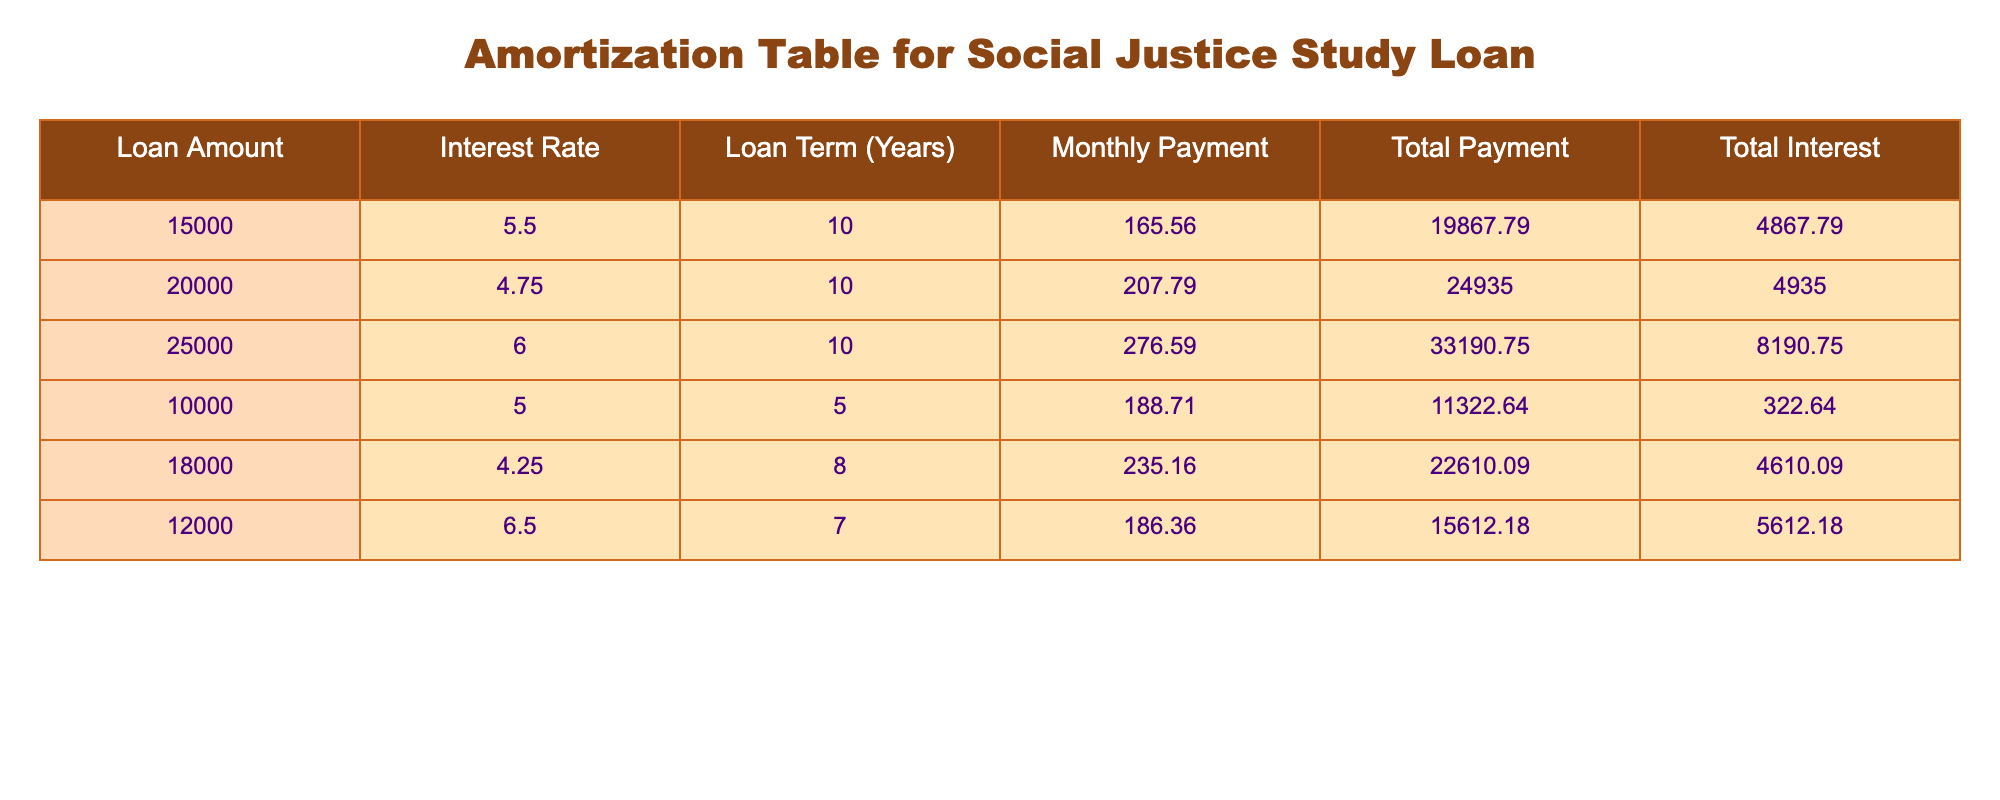What is the loan amount for the lowest total interest? Looking at the total interest column, the lowest total interest value is 322.64, which corresponds to the loan amount of 10,000.
Answer: 10000 Which loan has the highest monthly payment? The monthly payment column indicates that the loan with the highest monthly payment is 276.59, which corresponds to the loan amount of 25,000.
Answer: 25000 What is the total payment for a loan of 20,000? Referring to the total payment column, the total payment for the loan amount of 20,000 is 24,935.
Answer: 24935 Is the interest rate for the 12,000 loan higher than 5%? The interest rate for the loan amount of 12,000 is 6.5%, which is indeed higher than 5%.
Answer: Yes What is the total interest for a loan amount of 18,000? In the total interest column, for the loan amount of 18,000, the total interest is 4,610.09.
Answer: 4610.09 What is the average monthly payment across all loans? To find the average monthly payment, we sum all the monthly payments: (165.56 + 207.79 + 276.59 + 188.71 + 235.16 + 186.36) = 1260.17. Then, divide by the number of loans (6): 1260.17 / 6 = 210.03.
Answer: 210.03 Which loan has a term of 5 years? Referring to the loan term column, the loan of 10,000 has a term of 5 years.
Answer: 10000 Is the total payment for the 25,000 loan more than twice its loan amount? The total payment for the 25,000 loan is 33,190.75, which is more than twice its loan amount (2 * 25,000 = 50,000). Therefore, the statement is incorrect.
Answer: No Which loan has the lowest monthly payment and what is that payment? The loan with the lowest monthly payment is for 10,000 at 188.71.
Answer: 188.71 